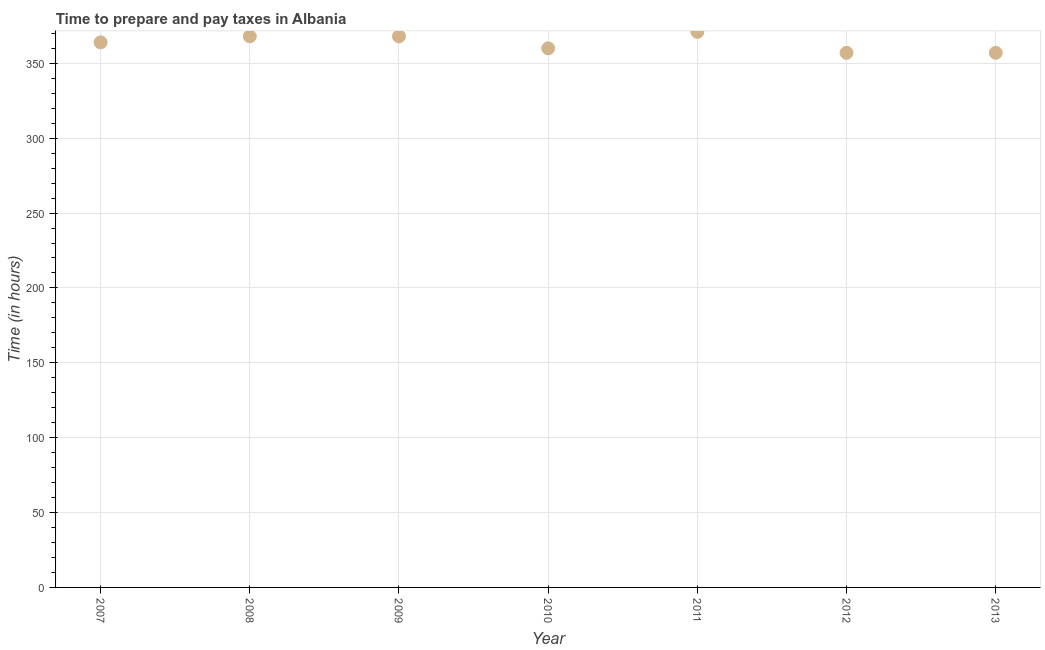What is the time to prepare and pay taxes in 2013?
Ensure brevity in your answer.  357. Across all years, what is the maximum time to prepare and pay taxes?
Your response must be concise. 371. Across all years, what is the minimum time to prepare and pay taxes?
Make the answer very short. 357. In which year was the time to prepare and pay taxes maximum?
Provide a succinct answer. 2011. In which year was the time to prepare and pay taxes minimum?
Offer a very short reply. 2012. What is the sum of the time to prepare and pay taxes?
Offer a terse response. 2545. What is the difference between the time to prepare and pay taxes in 2009 and 2012?
Give a very brief answer. 11. What is the average time to prepare and pay taxes per year?
Provide a short and direct response. 363.57. What is the median time to prepare and pay taxes?
Your answer should be very brief. 364. In how many years, is the time to prepare and pay taxes greater than 280 hours?
Give a very brief answer. 7. Do a majority of the years between 2010 and 2011 (inclusive) have time to prepare and pay taxes greater than 260 hours?
Your response must be concise. Yes. What is the ratio of the time to prepare and pay taxes in 2010 to that in 2011?
Make the answer very short. 0.97. Is the difference between the time to prepare and pay taxes in 2011 and 2013 greater than the difference between any two years?
Offer a terse response. Yes. What is the difference between the highest and the second highest time to prepare and pay taxes?
Provide a succinct answer. 3. What is the difference between the highest and the lowest time to prepare and pay taxes?
Keep it short and to the point. 14. How many dotlines are there?
Offer a terse response. 1. What is the difference between two consecutive major ticks on the Y-axis?
Ensure brevity in your answer.  50. Are the values on the major ticks of Y-axis written in scientific E-notation?
Your answer should be very brief. No. Does the graph contain any zero values?
Provide a succinct answer. No. What is the title of the graph?
Keep it short and to the point. Time to prepare and pay taxes in Albania. What is the label or title of the X-axis?
Ensure brevity in your answer.  Year. What is the label or title of the Y-axis?
Your response must be concise. Time (in hours). What is the Time (in hours) in 2007?
Provide a succinct answer. 364. What is the Time (in hours) in 2008?
Provide a succinct answer. 368. What is the Time (in hours) in 2009?
Provide a short and direct response. 368. What is the Time (in hours) in 2010?
Your response must be concise. 360. What is the Time (in hours) in 2011?
Provide a succinct answer. 371. What is the Time (in hours) in 2012?
Give a very brief answer. 357. What is the Time (in hours) in 2013?
Offer a terse response. 357. What is the difference between the Time (in hours) in 2007 and 2011?
Keep it short and to the point. -7. What is the difference between the Time (in hours) in 2007 and 2013?
Make the answer very short. 7. What is the difference between the Time (in hours) in 2008 and 2012?
Offer a very short reply. 11. What is the difference between the Time (in hours) in 2008 and 2013?
Keep it short and to the point. 11. What is the difference between the Time (in hours) in 2009 and 2012?
Ensure brevity in your answer.  11. What is the difference between the Time (in hours) in 2010 and 2012?
Offer a terse response. 3. What is the difference between the Time (in hours) in 2012 and 2013?
Give a very brief answer. 0. What is the ratio of the Time (in hours) in 2007 to that in 2008?
Your answer should be very brief. 0.99. What is the ratio of the Time (in hours) in 2007 to that in 2012?
Provide a short and direct response. 1.02. What is the ratio of the Time (in hours) in 2007 to that in 2013?
Ensure brevity in your answer.  1.02. What is the ratio of the Time (in hours) in 2008 to that in 2009?
Provide a short and direct response. 1. What is the ratio of the Time (in hours) in 2008 to that in 2010?
Your response must be concise. 1.02. What is the ratio of the Time (in hours) in 2008 to that in 2012?
Your response must be concise. 1.03. What is the ratio of the Time (in hours) in 2008 to that in 2013?
Your answer should be compact. 1.03. What is the ratio of the Time (in hours) in 2009 to that in 2010?
Give a very brief answer. 1.02. What is the ratio of the Time (in hours) in 2009 to that in 2012?
Give a very brief answer. 1.03. What is the ratio of the Time (in hours) in 2009 to that in 2013?
Provide a succinct answer. 1.03. What is the ratio of the Time (in hours) in 2010 to that in 2011?
Your answer should be very brief. 0.97. What is the ratio of the Time (in hours) in 2010 to that in 2012?
Give a very brief answer. 1.01. What is the ratio of the Time (in hours) in 2011 to that in 2012?
Offer a very short reply. 1.04. What is the ratio of the Time (in hours) in 2011 to that in 2013?
Your answer should be very brief. 1.04. What is the ratio of the Time (in hours) in 2012 to that in 2013?
Ensure brevity in your answer.  1. 